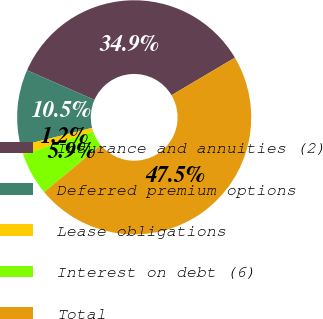Convert chart to OTSL. <chart><loc_0><loc_0><loc_500><loc_500><pie_chart><fcel>Insurance and annuities (2)<fcel>Deferred premium options<fcel>Lease obligations<fcel>Interest on debt (6)<fcel>Total<nl><fcel>34.9%<fcel>10.5%<fcel>1.25%<fcel>5.87%<fcel>47.48%<nl></chart> 